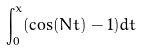<formula> <loc_0><loc_0><loc_500><loc_500>\int _ { 0 } ^ { x } ( \cos ( N t ) - 1 ) d t</formula> 